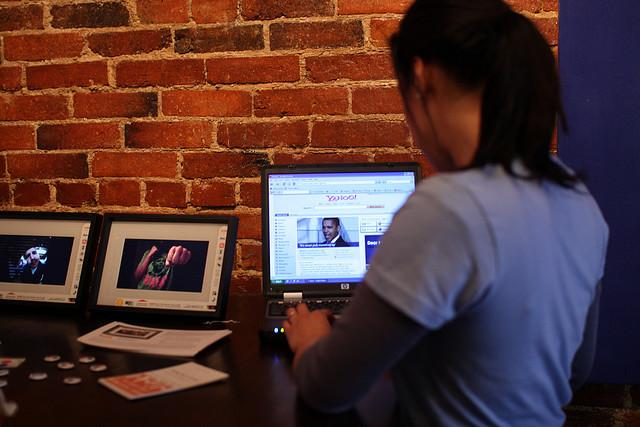In what year did the website on her screen become a company?

Choices:
A) 1999
B) 1994
C) 1998
D) 2003 1994 